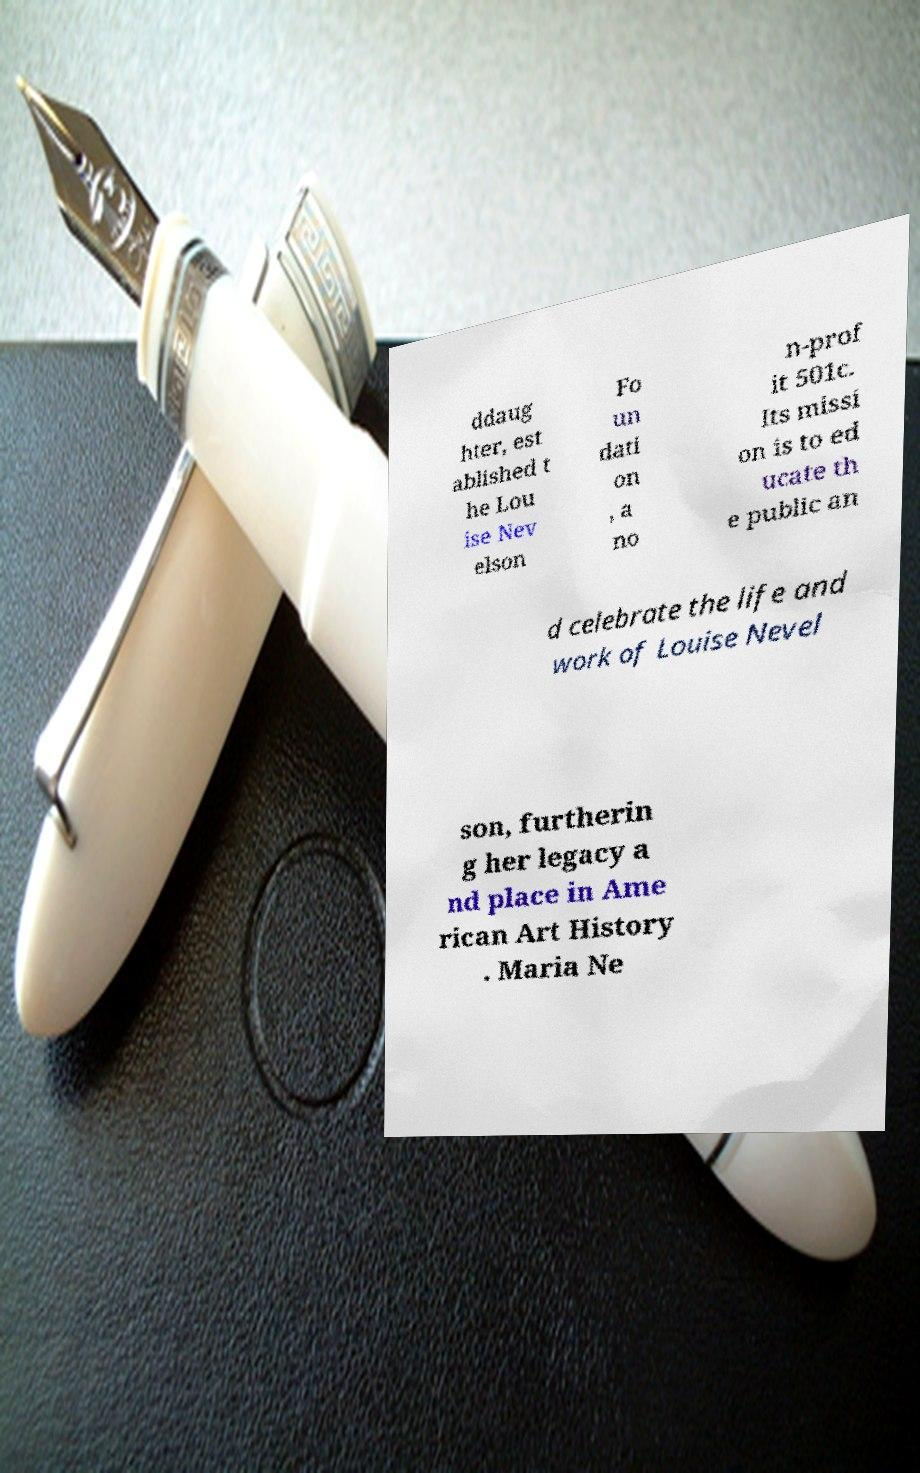Could you assist in decoding the text presented in this image and type it out clearly? ddaug hter, est ablished t he Lou ise Nev elson Fo un dati on , a no n-prof it 501c. Its missi on is to ed ucate th e public an d celebrate the life and work of Louise Nevel son, furtherin g her legacy a nd place in Ame rican Art History . Maria Ne 